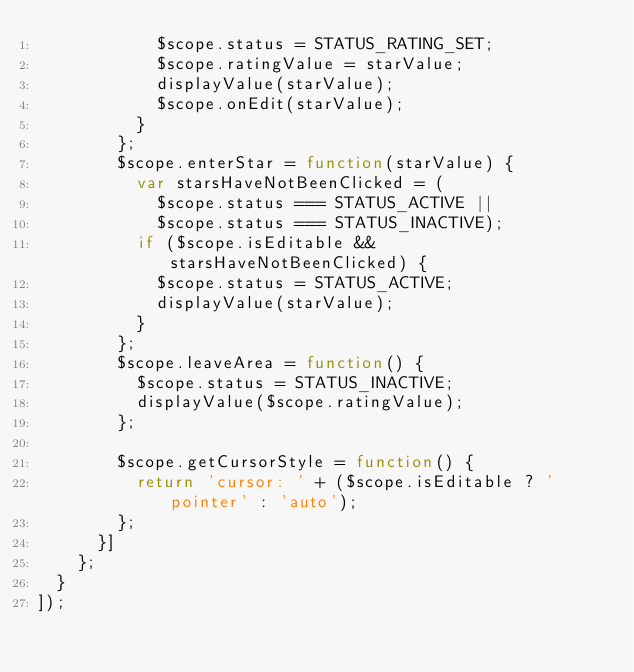<code> <loc_0><loc_0><loc_500><loc_500><_TypeScript_>            $scope.status = STATUS_RATING_SET;
            $scope.ratingValue = starValue;
            displayValue(starValue);
            $scope.onEdit(starValue);
          }
        };
        $scope.enterStar = function(starValue) {
          var starsHaveNotBeenClicked = (
            $scope.status === STATUS_ACTIVE ||
            $scope.status === STATUS_INACTIVE);
          if ($scope.isEditable && starsHaveNotBeenClicked) {
            $scope.status = STATUS_ACTIVE;
            displayValue(starValue);
          }
        };
        $scope.leaveArea = function() {
          $scope.status = STATUS_INACTIVE;
          displayValue($scope.ratingValue);
        };

        $scope.getCursorStyle = function() {
          return 'cursor: ' + ($scope.isEditable ? 'pointer' : 'auto');
        };
      }]
    };
  }
]);
</code> 